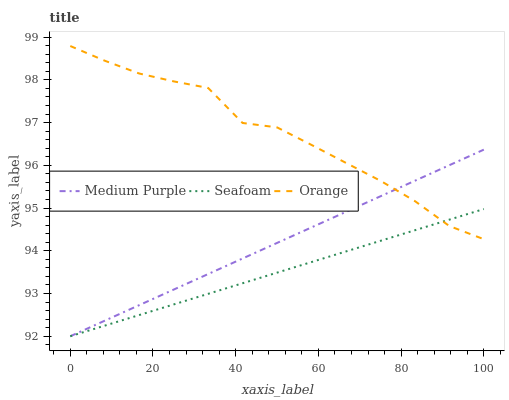Does Seafoam have the minimum area under the curve?
Answer yes or no. Yes. Does Orange have the maximum area under the curve?
Answer yes or no. Yes. Does Orange have the minimum area under the curve?
Answer yes or no. No. Does Seafoam have the maximum area under the curve?
Answer yes or no. No. Is Seafoam the smoothest?
Answer yes or no. Yes. Is Orange the roughest?
Answer yes or no. Yes. Is Orange the smoothest?
Answer yes or no. No. Is Seafoam the roughest?
Answer yes or no. No. Does Medium Purple have the lowest value?
Answer yes or no. Yes. Does Orange have the lowest value?
Answer yes or no. No. Does Orange have the highest value?
Answer yes or no. Yes. Does Seafoam have the highest value?
Answer yes or no. No. Does Seafoam intersect Medium Purple?
Answer yes or no. Yes. Is Seafoam less than Medium Purple?
Answer yes or no. No. Is Seafoam greater than Medium Purple?
Answer yes or no. No. 